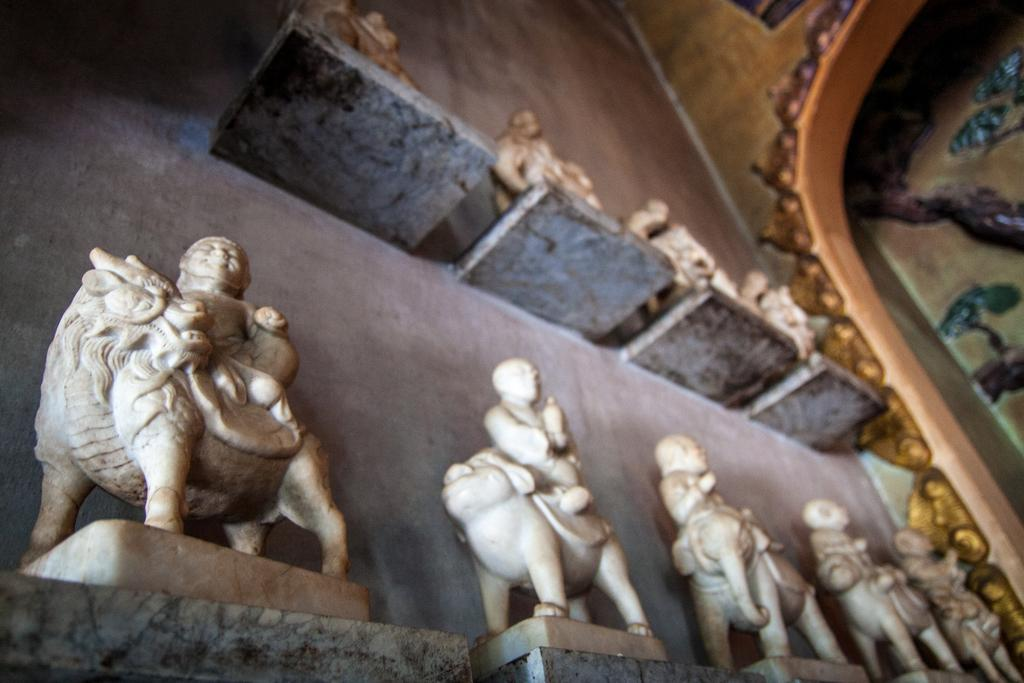What is present on the shelves in the image? There are idols on the shelves in the image. How are the shelves arranged in the image? The shelves are attached to a wall in the image. What can be seen on the wall in the image? The wall has sculptures in the image. Can you see a mask with a smile on the idols in the image? There is no mask or smile present on the idols in the image. What type of coil is wrapped around the idols in the image? There is no coil present around the idols in the image. 